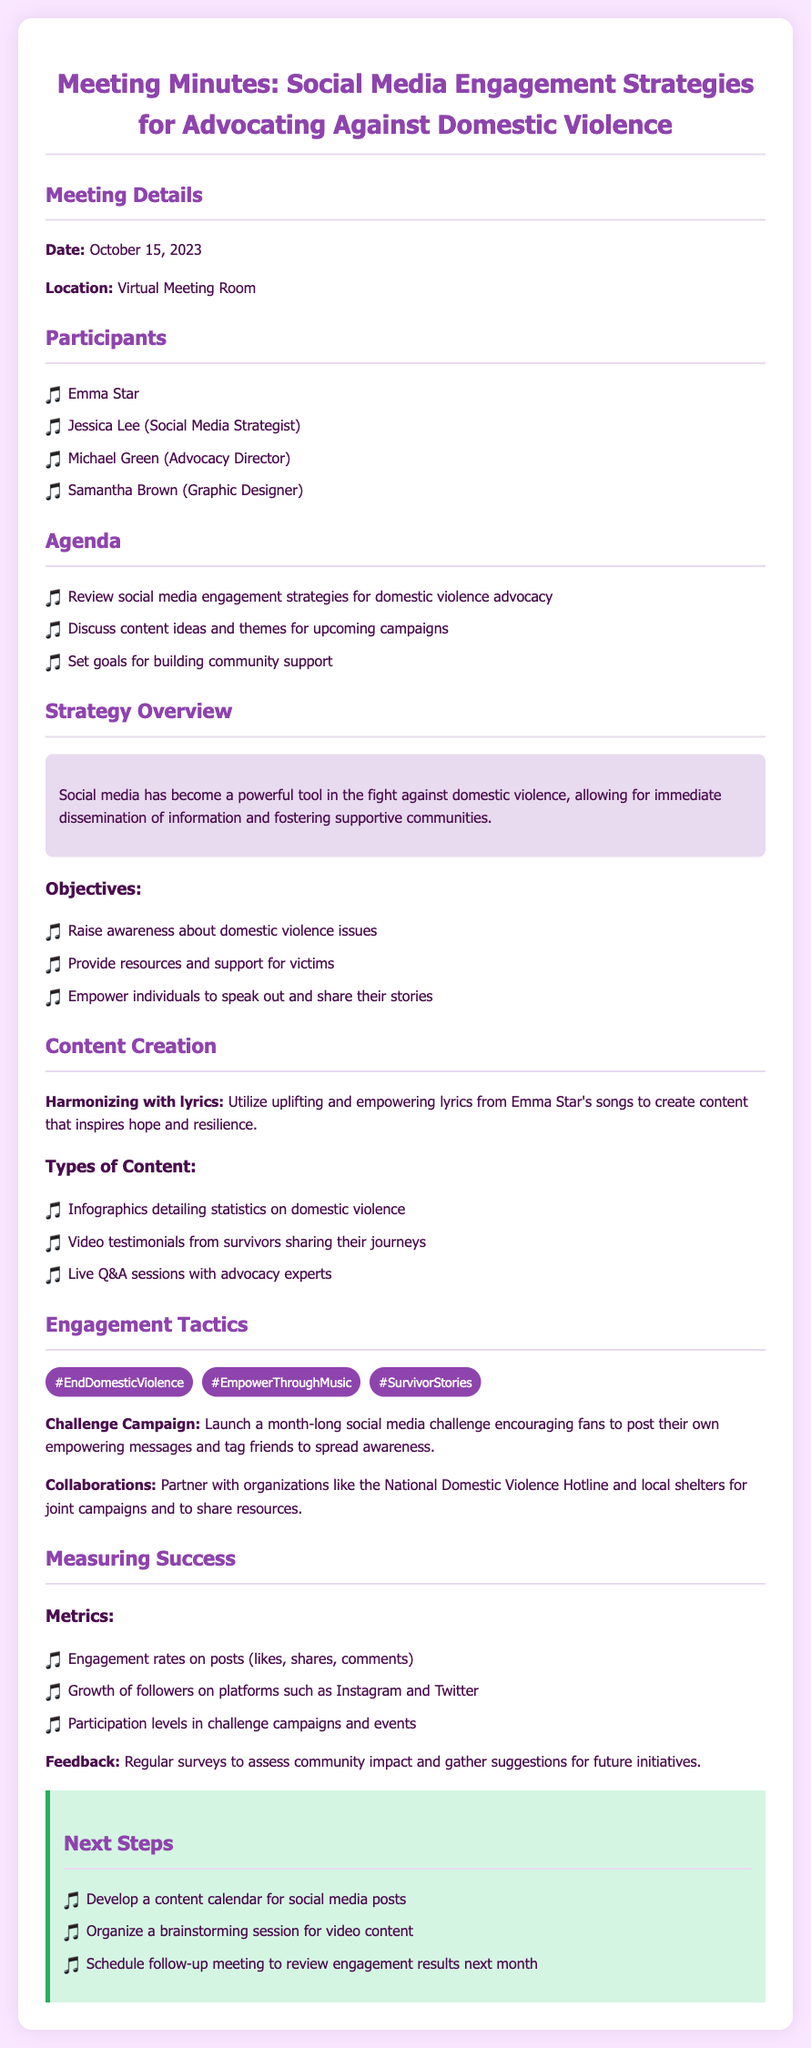what was the date of the meeting? The date of the meeting is specified at the beginning of the document.
Answer: October 15, 2023 who is the Social Media Strategist mentioned in the meeting? The participants section lists the names and roles of attendees, including the Social Media Strategist.
Answer: Jessica Lee what is one of the objectives mentioned in the document? The objectives section outlines goals for the social media engagement strategies, including awareness and support.
Answer: Raise awareness about domestic violence issues which hashtag promotes empowerment through music? The document lists several hashtags that are relevant to the campaign.
Answer: #EmpowerThroughMusic how will the success be measured according to the document? The metrics section provides various means to assess the effectiveness of the strategies discussed in the meeting.
Answer: Engagement rates on posts what is one type of content planned for creation? The content creation section lists various content types that will be developed for the advocacy efforts.
Answer: Video testimonials from survivors sharing their journeys what campaign encourages fans to post their own messages? The engagement tactics section describes a specific campaign aimed at fostering community participation.
Answer: Challenge Campaign how will community impact be assessed according to the document? The feedback section mentions a method for gathering opinions from the community regarding the initiatives.
Answer: Regular surveys 